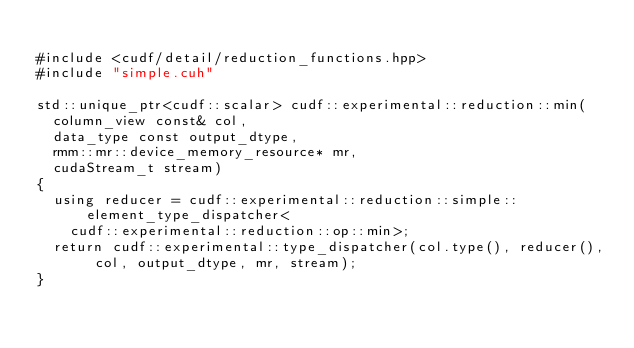Convert code to text. <code><loc_0><loc_0><loc_500><loc_500><_Cuda_>
#include <cudf/detail/reduction_functions.hpp>
#include "simple.cuh"

std::unique_ptr<cudf::scalar> cudf::experimental::reduction::min(
  column_view const& col,
  data_type const output_dtype,
  rmm::mr::device_memory_resource* mr,
  cudaStream_t stream)
{
  using reducer = cudf::experimental::reduction::simple::element_type_dispatcher<
    cudf::experimental::reduction::op::min>;
  return cudf::experimental::type_dispatcher(col.type(), reducer(), col, output_dtype, mr, stream);
}
</code> 